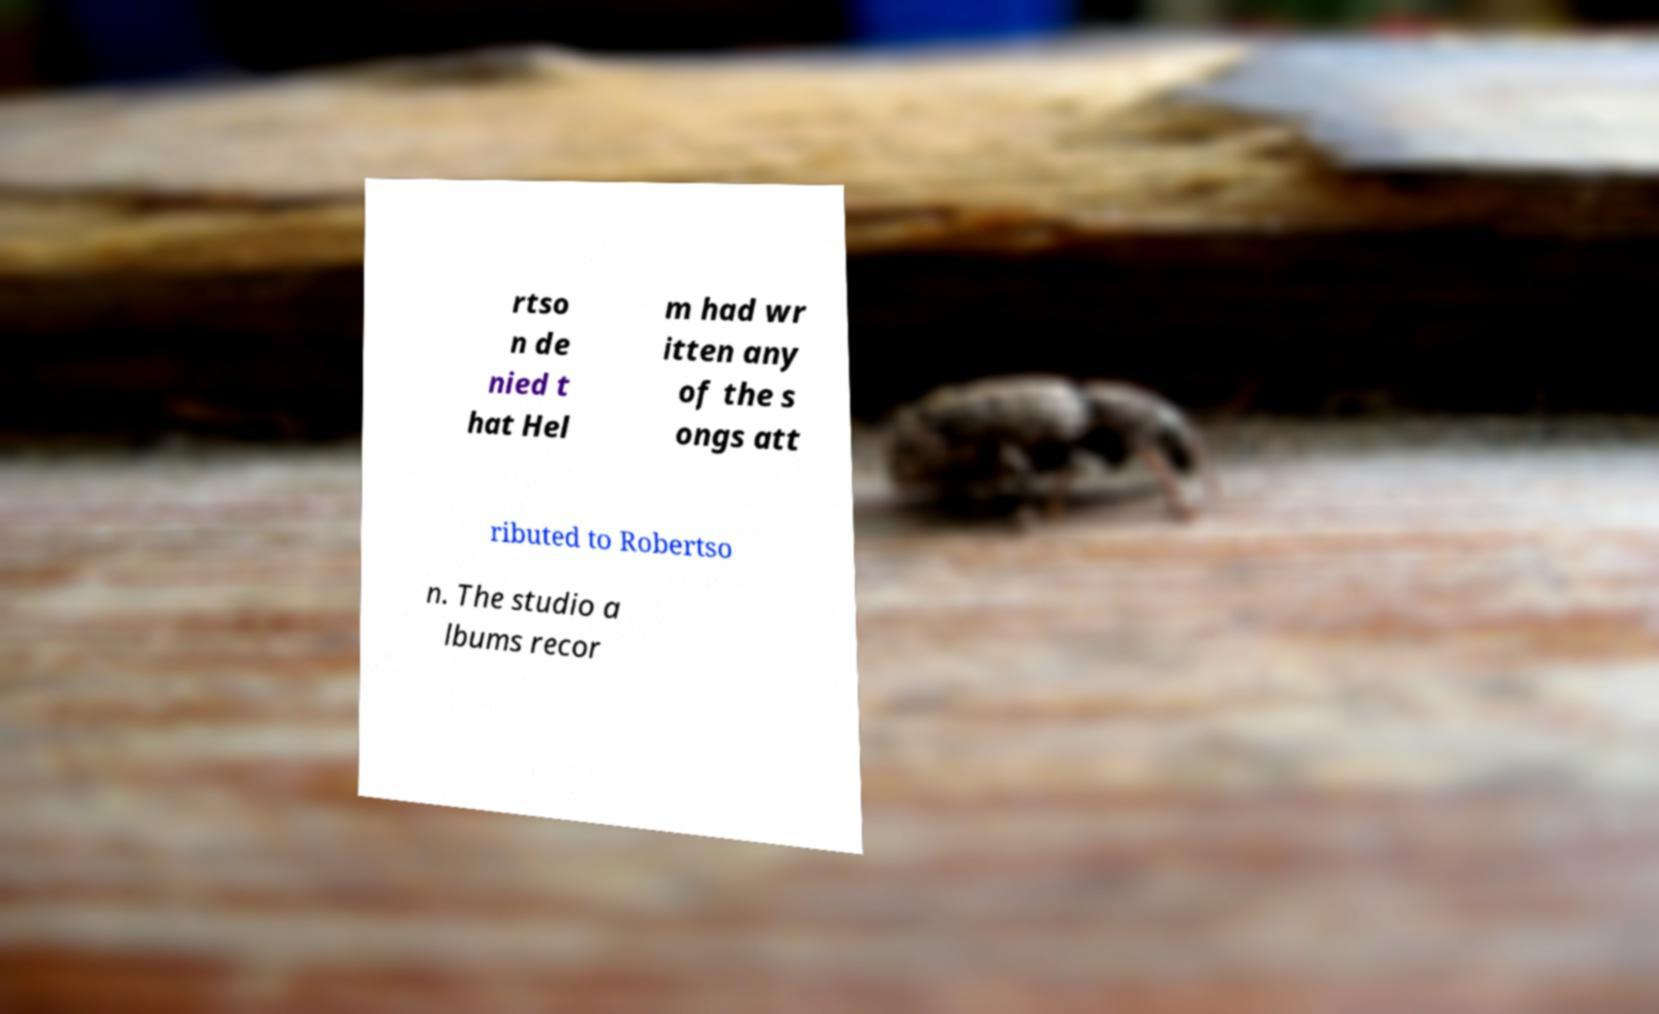Could you assist in decoding the text presented in this image and type it out clearly? rtso n de nied t hat Hel m had wr itten any of the s ongs att ributed to Robertso n. The studio a lbums recor 